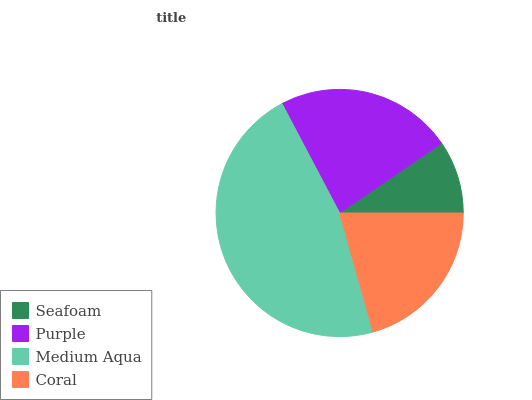Is Seafoam the minimum?
Answer yes or no. Yes. Is Medium Aqua the maximum?
Answer yes or no. Yes. Is Purple the minimum?
Answer yes or no. No. Is Purple the maximum?
Answer yes or no. No. Is Purple greater than Seafoam?
Answer yes or no. Yes. Is Seafoam less than Purple?
Answer yes or no. Yes. Is Seafoam greater than Purple?
Answer yes or no. No. Is Purple less than Seafoam?
Answer yes or no. No. Is Purple the high median?
Answer yes or no. Yes. Is Coral the low median?
Answer yes or no. Yes. Is Medium Aqua the high median?
Answer yes or no. No. Is Medium Aqua the low median?
Answer yes or no. No. 